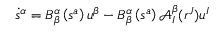Convert formula to latex. <formula><loc_0><loc_0><loc_500><loc_500>\dot { s } ^ { \alpha } = B _ { \beta } ^ { \alpha } \left ( s ^ { a } \right ) u ^ { \beta } - B _ { \beta } ^ { \alpha } \left ( s ^ { a } \right ) \mathcal { A } _ { I } ^ { \beta } ( r ^ { J } ) u ^ { I }</formula> 